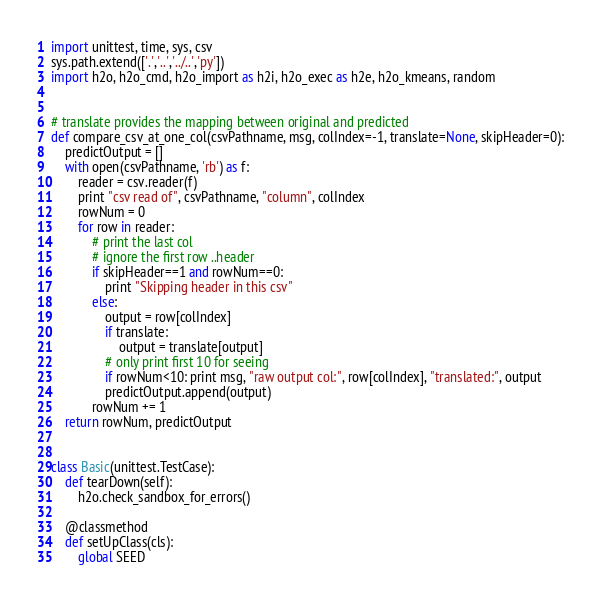Convert code to text. <code><loc_0><loc_0><loc_500><loc_500><_Python_>import unittest, time, sys, csv
sys.path.extend(['.','..','../..','py'])
import h2o, h2o_cmd, h2o_import as h2i, h2o_exec as h2e, h2o_kmeans, random


# translate provides the mapping between original and predicted
def compare_csv_at_one_col(csvPathname, msg, colIndex=-1, translate=None, skipHeader=0):
    predictOutput = []
    with open(csvPathname, 'rb') as f:
        reader = csv.reader(f)
        print "csv read of", csvPathname, "column", colIndex
        rowNum = 0
        for row in reader:
            # print the last col
            # ignore the first row ..header
            if skipHeader==1 and rowNum==0:
                print "Skipping header in this csv"
            else:
                output = row[colIndex]
                if translate:
                    output = translate[output]
                # only print first 10 for seeing
                if rowNum<10: print msg, "raw output col:", row[colIndex], "translated:", output
                predictOutput.append(output)
            rowNum += 1
    return rowNum, predictOutput


class Basic(unittest.TestCase):
    def tearDown(self):
        h2o.check_sandbox_for_errors()

    @classmethod
    def setUpClass(cls):
        global SEED</code> 